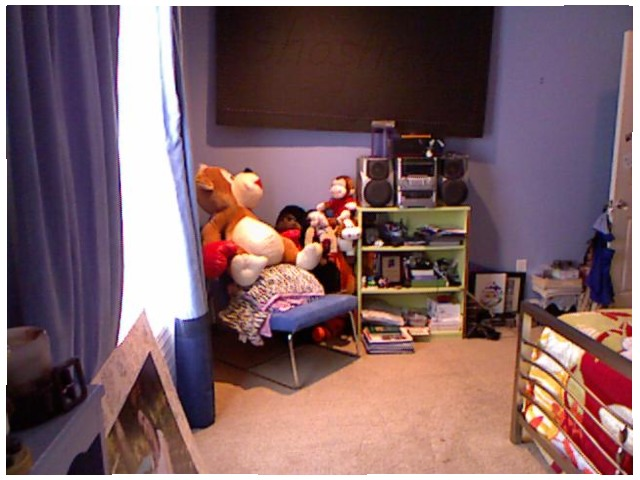<image>
Can you confirm if the blanket is in front of the chair? No. The blanket is not in front of the chair. The spatial positioning shows a different relationship between these objects. Is the teddy bear on the chair? Yes. Looking at the image, I can see the teddy bear is positioned on top of the chair, with the chair providing support. Where is the toy in relation to the bed? Is it behind the bed? Yes. From this viewpoint, the toy is positioned behind the bed, with the bed partially or fully occluding the toy. 